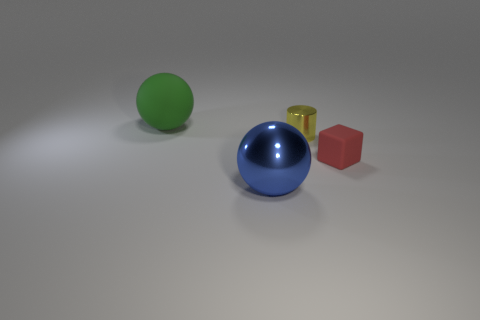How many matte things are in front of the yellow object?
Keep it short and to the point. 1. What material is the object that is both in front of the small cylinder and behind the big blue thing?
Keep it short and to the point. Rubber. How many tiny objects are either green matte balls or cyan shiny cylinders?
Your answer should be very brief. 0. The green ball is what size?
Your response must be concise. Large. What shape is the small red object?
Offer a very short reply. Cube. Is there anything else that is the same shape as the tiny rubber thing?
Keep it short and to the point. No. Are there fewer small cubes that are on the left side of the large green ball than blue metallic objects?
Offer a terse response. Yes. What number of shiny things are either big green balls or red blocks?
Offer a very short reply. 0. What color is the large ball that is made of the same material as the yellow cylinder?
Your answer should be compact. Blue. What number of cylinders are either matte things or yellow objects?
Your response must be concise. 1. 